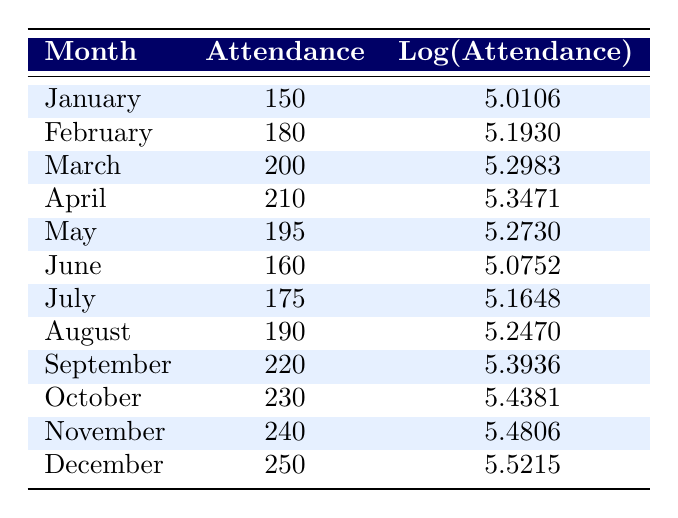What was the attendance in October? The table shows that the attendance for October is listed directly. We see the row corresponding to October indicates an attendance of 230.
Answer: 230 Which month had the highest attendance? Looking through the attendance figures for all months, December shows the highest attendance at 250. Other months have lower numbers.
Answer: December What is the log(Attendance) for September? The log(Attendance) value is provided directly in the table for each month. For September, this value is 5.3936.
Answer: 5.3936 What is the average attendance from January to June? To find the average attendance from January to June, we sum the attendance figures for these months: (150 + 180 + 200 + 210 + 195 + 160) = 1095. Then, we divide by the number of months, which is 6. Thus, the average is 1095/6 = 182.5.
Answer: 182.5 Is the attendance in April greater than in March? By comparing the figures for both months in the table, April shows an attendance of 210 and March shows 200. Since 210 is greater than 200, the answer is yes.
Answer: Yes How much did attendance increase from January to December? We look at the figures for January and December, which are 150 and 250, respectively. The increase is calculated as 250 - 150 = 100.
Answer: 100 Which month had attendance less than 200? By examining the table, we can find the months with attendance less than 200, which are January (150), June (160), and July (175).
Answer: January, June, July What is the difference in log(Attendance) between November and January? First, we find the log(Attendance) for November which is 5.4806 and for January which is 5.0106. The difference is calculated as 5.4806 - 5.0106 = 0.4700.
Answer: 0.4700 Did the attendance grow continuously from January to December? By analyzing the numbers in the table, we see that attendance rises in most months, except for June, which is lower than May. Hence, the attendance does not grow continuously throughout the year.
Answer: No 